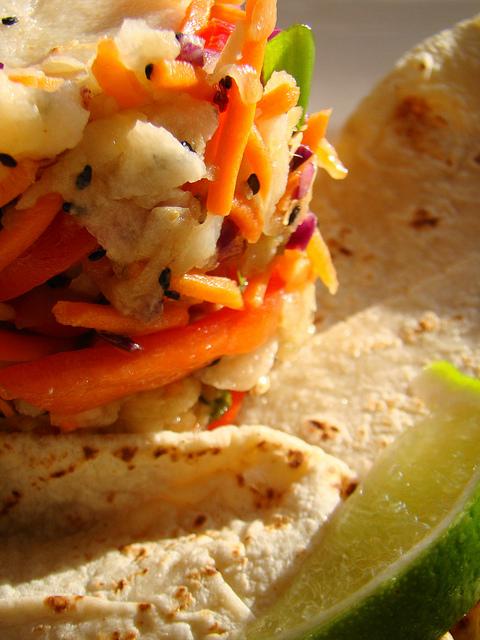Are there veggies?
Quick response, please. Yes. What are the orange bits?
Give a very brief answer. Carrots. Is there a lime wedge pictured?
Concise answer only. Yes. 